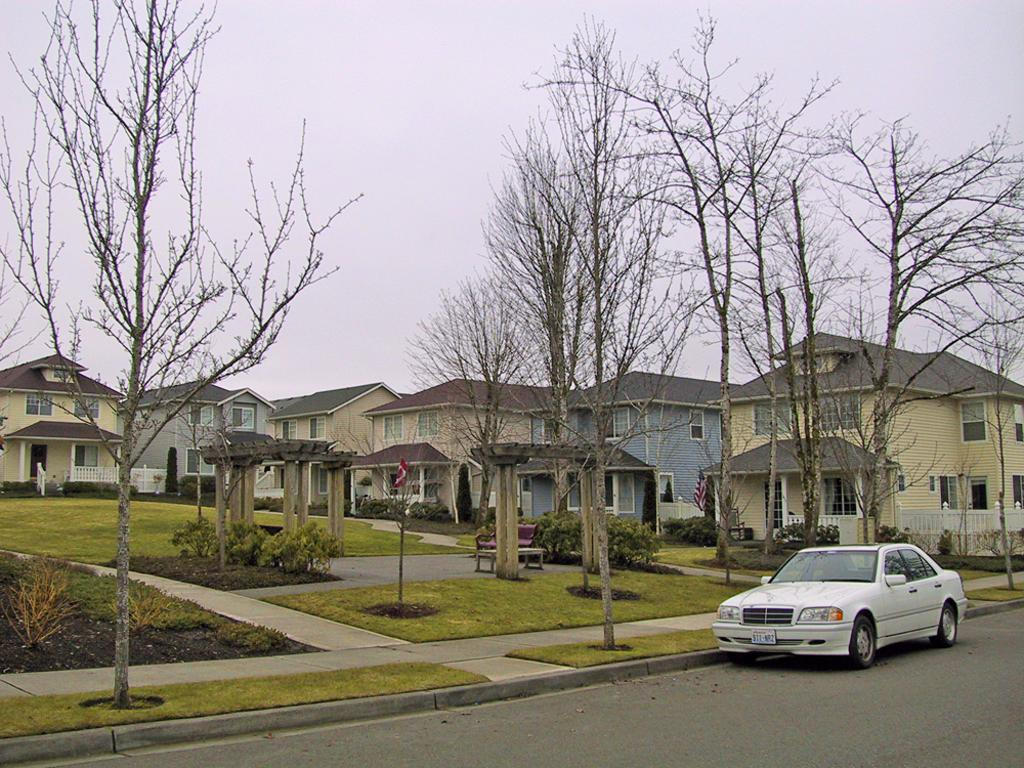What type of natural elements can be seen in the image? There are trees in the image. What type of man-made structures are present in the image? There are buildings in the image. What mode of transportation can be seen on the road in the image? There is a car on the road in the image. What architectural feature is present in the middle of the image? There are arches in the middle of the image. What is visible in the background of the image? The sky is visible in the background of the image. What type of honey is being collected from the trees in the image? There is no honey or honey collection process depicted in the image; it features trees, buildings, a car, arches, and the sky. What type of gold is present in the image? There is no gold present in the image. 